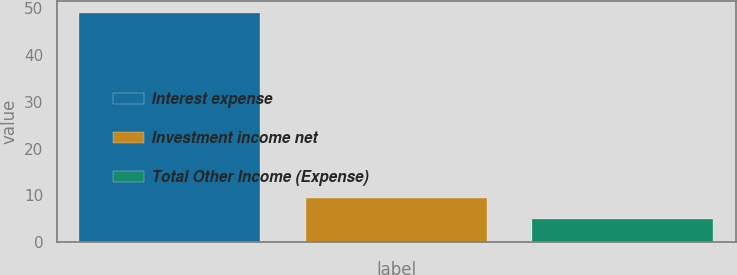<chart> <loc_0><loc_0><loc_500><loc_500><bar_chart><fcel>Interest expense<fcel>Investment income net<fcel>Total Other Income (Expense)<nl><fcel>49<fcel>9.4<fcel>5<nl></chart> 